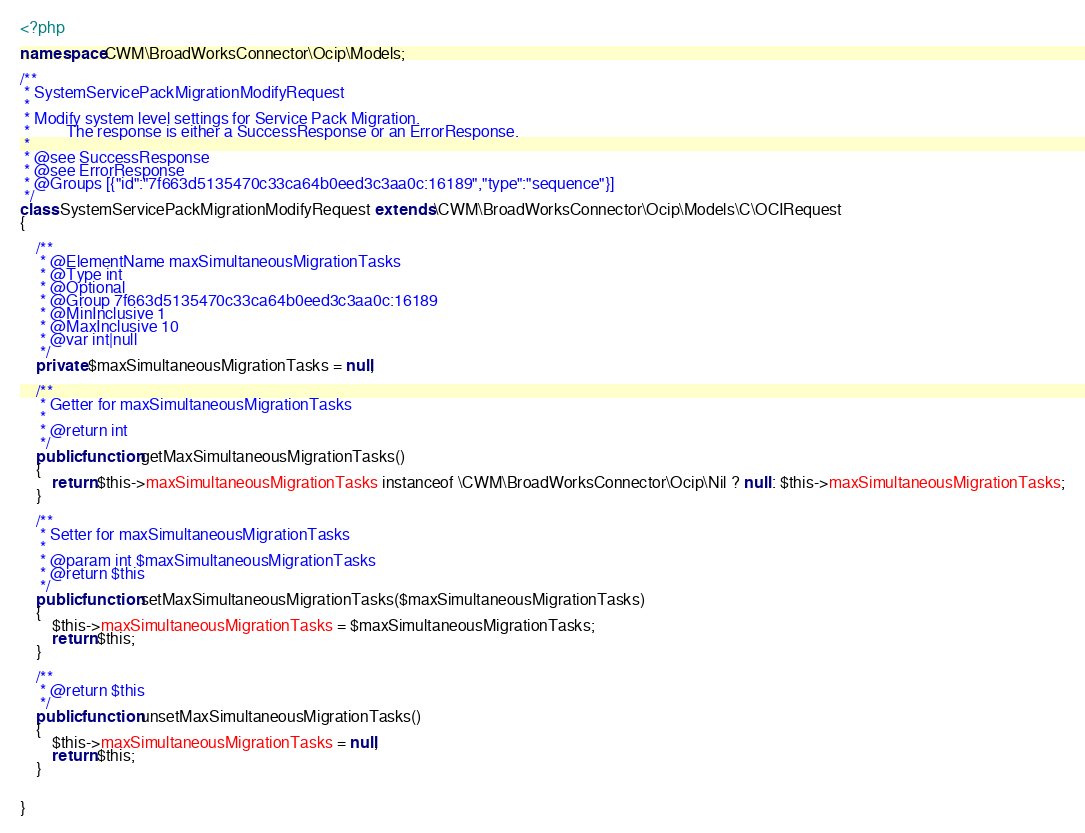Convert code to text. <code><loc_0><loc_0><loc_500><loc_500><_PHP_><?php

namespace CWM\BroadWorksConnector\Ocip\Models;

/**
 * SystemServicePackMigrationModifyRequest
 *
 * Modify system level settings for Service Pack Migration.
 *         The response is either a SuccessResponse or an ErrorResponse.
 *
 * @see SuccessResponse
 * @see ErrorResponse
 * @Groups [{"id":"7f663d5135470c33ca64b0eed3c3aa0c:16189","type":"sequence"}]
 */
class SystemServicePackMigrationModifyRequest extends \CWM\BroadWorksConnector\Ocip\Models\C\OCIRequest
{

    /**
     * @ElementName maxSimultaneousMigrationTasks
     * @Type int
     * @Optional
     * @Group 7f663d5135470c33ca64b0eed3c3aa0c:16189
     * @MinInclusive 1
     * @MaxInclusive 10
     * @var int|null
     */
    private $maxSimultaneousMigrationTasks = null;

    /**
     * Getter for maxSimultaneousMigrationTasks
     *
     * @return int
     */
    public function getMaxSimultaneousMigrationTasks()
    {
        return $this->maxSimultaneousMigrationTasks instanceof \CWM\BroadWorksConnector\Ocip\Nil ? null : $this->maxSimultaneousMigrationTasks;
    }

    /**
     * Setter for maxSimultaneousMigrationTasks
     *
     * @param int $maxSimultaneousMigrationTasks
     * @return $this
     */
    public function setMaxSimultaneousMigrationTasks($maxSimultaneousMigrationTasks)
    {
        $this->maxSimultaneousMigrationTasks = $maxSimultaneousMigrationTasks;
        return $this;
    }

    /**
     * @return $this
     */
    public function unsetMaxSimultaneousMigrationTasks()
    {
        $this->maxSimultaneousMigrationTasks = null;
        return $this;
    }


}

</code> 